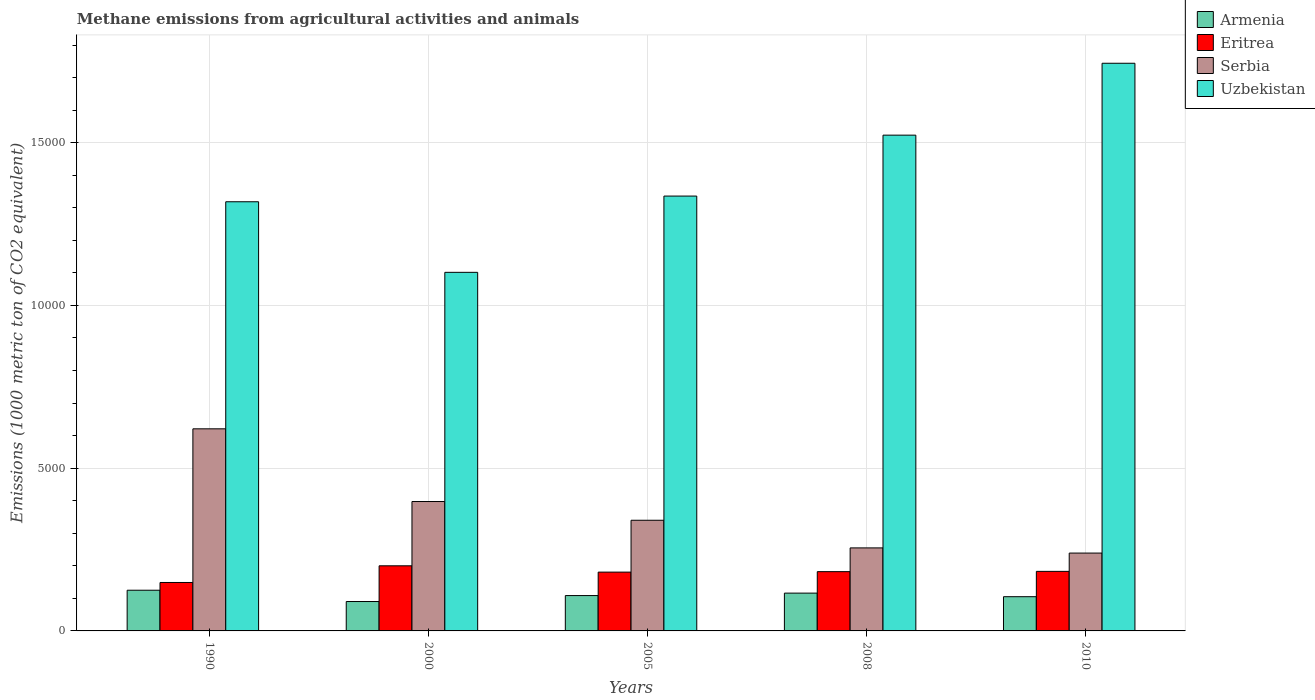How many different coloured bars are there?
Your response must be concise. 4. Are the number of bars per tick equal to the number of legend labels?
Offer a very short reply. Yes. What is the label of the 4th group of bars from the left?
Keep it short and to the point. 2008. In how many cases, is the number of bars for a given year not equal to the number of legend labels?
Your response must be concise. 0. What is the amount of methane emitted in Armenia in 1990?
Your response must be concise. 1250.4. Across all years, what is the maximum amount of methane emitted in Eritrea?
Your answer should be compact. 2000.3. Across all years, what is the minimum amount of methane emitted in Armenia?
Give a very brief answer. 903.1. In which year was the amount of methane emitted in Eritrea maximum?
Offer a very short reply. 2000. In which year was the amount of methane emitted in Uzbekistan minimum?
Provide a short and direct response. 2000. What is the total amount of methane emitted in Serbia in the graph?
Ensure brevity in your answer.  1.85e+04. What is the difference between the amount of methane emitted in Serbia in 2005 and that in 2010?
Offer a terse response. 1007.9. What is the difference between the amount of methane emitted in Eritrea in 2000 and the amount of methane emitted in Serbia in 1990?
Provide a short and direct response. -4208.5. What is the average amount of methane emitted in Eritrea per year?
Ensure brevity in your answer.  1789.12. In the year 2005, what is the difference between the amount of methane emitted in Serbia and amount of methane emitted in Eritrea?
Offer a very short reply. 1593. What is the ratio of the amount of methane emitted in Eritrea in 2000 to that in 2008?
Offer a terse response. 1.1. Is the amount of methane emitted in Eritrea in 2000 less than that in 2010?
Offer a very short reply. No. What is the difference between the highest and the second highest amount of methane emitted in Uzbekistan?
Provide a succinct answer. 2208.5. What is the difference between the highest and the lowest amount of methane emitted in Serbia?
Offer a terse response. 3817.1. Is the sum of the amount of methane emitted in Uzbekistan in 2008 and 2010 greater than the maximum amount of methane emitted in Serbia across all years?
Offer a very short reply. Yes. What does the 1st bar from the left in 2010 represents?
Keep it short and to the point. Armenia. What does the 2nd bar from the right in 2005 represents?
Your answer should be compact. Serbia. Is it the case that in every year, the sum of the amount of methane emitted in Eritrea and amount of methane emitted in Uzbekistan is greater than the amount of methane emitted in Armenia?
Offer a very short reply. Yes. What is the difference between two consecutive major ticks on the Y-axis?
Offer a very short reply. 5000. Are the values on the major ticks of Y-axis written in scientific E-notation?
Give a very brief answer. No. Does the graph contain any zero values?
Give a very brief answer. No. How many legend labels are there?
Your answer should be compact. 4. What is the title of the graph?
Provide a short and direct response. Methane emissions from agricultural activities and animals. What is the label or title of the Y-axis?
Offer a very short reply. Emissions (1000 metric ton of CO2 equivalent). What is the Emissions (1000 metric ton of CO2 equivalent) in Armenia in 1990?
Offer a very short reply. 1250.4. What is the Emissions (1000 metric ton of CO2 equivalent) of Eritrea in 1990?
Give a very brief answer. 1488.1. What is the Emissions (1000 metric ton of CO2 equivalent) in Serbia in 1990?
Ensure brevity in your answer.  6208.8. What is the Emissions (1000 metric ton of CO2 equivalent) of Uzbekistan in 1990?
Your response must be concise. 1.32e+04. What is the Emissions (1000 metric ton of CO2 equivalent) of Armenia in 2000?
Ensure brevity in your answer.  903.1. What is the Emissions (1000 metric ton of CO2 equivalent) in Eritrea in 2000?
Your answer should be compact. 2000.3. What is the Emissions (1000 metric ton of CO2 equivalent) of Serbia in 2000?
Your answer should be compact. 3975.3. What is the Emissions (1000 metric ton of CO2 equivalent) of Uzbekistan in 2000?
Offer a terse response. 1.10e+04. What is the Emissions (1000 metric ton of CO2 equivalent) in Armenia in 2005?
Offer a very short reply. 1086. What is the Emissions (1000 metric ton of CO2 equivalent) of Eritrea in 2005?
Keep it short and to the point. 1806.6. What is the Emissions (1000 metric ton of CO2 equivalent) in Serbia in 2005?
Your answer should be compact. 3399.6. What is the Emissions (1000 metric ton of CO2 equivalent) in Uzbekistan in 2005?
Ensure brevity in your answer.  1.34e+04. What is the Emissions (1000 metric ton of CO2 equivalent) of Armenia in 2008?
Your response must be concise. 1161.5. What is the Emissions (1000 metric ton of CO2 equivalent) of Eritrea in 2008?
Make the answer very short. 1820.8. What is the Emissions (1000 metric ton of CO2 equivalent) of Serbia in 2008?
Keep it short and to the point. 2550.7. What is the Emissions (1000 metric ton of CO2 equivalent) in Uzbekistan in 2008?
Offer a very short reply. 1.52e+04. What is the Emissions (1000 metric ton of CO2 equivalent) of Armenia in 2010?
Your response must be concise. 1051.7. What is the Emissions (1000 metric ton of CO2 equivalent) of Eritrea in 2010?
Offer a very short reply. 1829.8. What is the Emissions (1000 metric ton of CO2 equivalent) of Serbia in 2010?
Offer a very short reply. 2391.7. What is the Emissions (1000 metric ton of CO2 equivalent) of Uzbekistan in 2010?
Make the answer very short. 1.74e+04. Across all years, what is the maximum Emissions (1000 metric ton of CO2 equivalent) in Armenia?
Keep it short and to the point. 1250.4. Across all years, what is the maximum Emissions (1000 metric ton of CO2 equivalent) of Eritrea?
Your answer should be very brief. 2000.3. Across all years, what is the maximum Emissions (1000 metric ton of CO2 equivalent) in Serbia?
Your answer should be compact. 6208.8. Across all years, what is the maximum Emissions (1000 metric ton of CO2 equivalent) of Uzbekistan?
Give a very brief answer. 1.74e+04. Across all years, what is the minimum Emissions (1000 metric ton of CO2 equivalent) of Armenia?
Give a very brief answer. 903.1. Across all years, what is the minimum Emissions (1000 metric ton of CO2 equivalent) in Eritrea?
Your answer should be compact. 1488.1. Across all years, what is the minimum Emissions (1000 metric ton of CO2 equivalent) of Serbia?
Ensure brevity in your answer.  2391.7. Across all years, what is the minimum Emissions (1000 metric ton of CO2 equivalent) in Uzbekistan?
Provide a short and direct response. 1.10e+04. What is the total Emissions (1000 metric ton of CO2 equivalent) in Armenia in the graph?
Give a very brief answer. 5452.7. What is the total Emissions (1000 metric ton of CO2 equivalent) in Eritrea in the graph?
Make the answer very short. 8945.6. What is the total Emissions (1000 metric ton of CO2 equivalent) of Serbia in the graph?
Ensure brevity in your answer.  1.85e+04. What is the total Emissions (1000 metric ton of CO2 equivalent) in Uzbekistan in the graph?
Offer a very short reply. 7.02e+04. What is the difference between the Emissions (1000 metric ton of CO2 equivalent) in Armenia in 1990 and that in 2000?
Make the answer very short. 347.3. What is the difference between the Emissions (1000 metric ton of CO2 equivalent) in Eritrea in 1990 and that in 2000?
Make the answer very short. -512.2. What is the difference between the Emissions (1000 metric ton of CO2 equivalent) of Serbia in 1990 and that in 2000?
Give a very brief answer. 2233.5. What is the difference between the Emissions (1000 metric ton of CO2 equivalent) of Uzbekistan in 1990 and that in 2000?
Ensure brevity in your answer.  2168. What is the difference between the Emissions (1000 metric ton of CO2 equivalent) in Armenia in 1990 and that in 2005?
Offer a terse response. 164.4. What is the difference between the Emissions (1000 metric ton of CO2 equivalent) of Eritrea in 1990 and that in 2005?
Provide a succinct answer. -318.5. What is the difference between the Emissions (1000 metric ton of CO2 equivalent) in Serbia in 1990 and that in 2005?
Offer a terse response. 2809.2. What is the difference between the Emissions (1000 metric ton of CO2 equivalent) in Uzbekistan in 1990 and that in 2005?
Offer a very short reply. -174.6. What is the difference between the Emissions (1000 metric ton of CO2 equivalent) of Armenia in 1990 and that in 2008?
Your answer should be compact. 88.9. What is the difference between the Emissions (1000 metric ton of CO2 equivalent) of Eritrea in 1990 and that in 2008?
Ensure brevity in your answer.  -332.7. What is the difference between the Emissions (1000 metric ton of CO2 equivalent) of Serbia in 1990 and that in 2008?
Give a very brief answer. 3658.1. What is the difference between the Emissions (1000 metric ton of CO2 equivalent) of Uzbekistan in 1990 and that in 2008?
Provide a succinct answer. -2046.5. What is the difference between the Emissions (1000 metric ton of CO2 equivalent) of Armenia in 1990 and that in 2010?
Offer a terse response. 198.7. What is the difference between the Emissions (1000 metric ton of CO2 equivalent) in Eritrea in 1990 and that in 2010?
Your answer should be compact. -341.7. What is the difference between the Emissions (1000 metric ton of CO2 equivalent) of Serbia in 1990 and that in 2010?
Ensure brevity in your answer.  3817.1. What is the difference between the Emissions (1000 metric ton of CO2 equivalent) in Uzbekistan in 1990 and that in 2010?
Provide a succinct answer. -4255. What is the difference between the Emissions (1000 metric ton of CO2 equivalent) of Armenia in 2000 and that in 2005?
Provide a short and direct response. -182.9. What is the difference between the Emissions (1000 metric ton of CO2 equivalent) of Eritrea in 2000 and that in 2005?
Keep it short and to the point. 193.7. What is the difference between the Emissions (1000 metric ton of CO2 equivalent) of Serbia in 2000 and that in 2005?
Keep it short and to the point. 575.7. What is the difference between the Emissions (1000 metric ton of CO2 equivalent) in Uzbekistan in 2000 and that in 2005?
Provide a short and direct response. -2342.6. What is the difference between the Emissions (1000 metric ton of CO2 equivalent) of Armenia in 2000 and that in 2008?
Keep it short and to the point. -258.4. What is the difference between the Emissions (1000 metric ton of CO2 equivalent) in Eritrea in 2000 and that in 2008?
Give a very brief answer. 179.5. What is the difference between the Emissions (1000 metric ton of CO2 equivalent) in Serbia in 2000 and that in 2008?
Ensure brevity in your answer.  1424.6. What is the difference between the Emissions (1000 metric ton of CO2 equivalent) of Uzbekistan in 2000 and that in 2008?
Provide a succinct answer. -4214.5. What is the difference between the Emissions (1000 metric ton of CO2 equivalent) in Armenia in 2000 and that in 2010?
Provide a short and direct response. -148.6. What is the difference between the Emissions (1000 metric ton of CO2 equivalent) in Eritrea in 2000 and that in 2010?
Keep it short and to the point. 170.5. What is the difference between the Emissions (1000 metric ton of CO2 equivalent) of Serbia in 2000 and that in 2010?
Your answer should be compact. 1583.6. What is the difference between the Emissions (1000 metric ton of CO2 equivalent) in Uzbekistan in 2000 and that in 2010?
Your answer should be compact. -6423. What is the difference between the Emissions (1000 metric ton of CO2 equivalent) of Armenia in 2005 and that in 2008?
Offer a very short reply. -75.5. What is the difference between the Emissions (1000 metric ton of CO2 equivalent) in Eritrea in 2005 and that in 2008?
Offer a terse response. -14.2. What is the difference between the Emissions (1000 metric ton of CO2 equivalent) of Serbia in 2005 and that in 2008?
Provide a succinct answer. 848.9. What is the difference between the Emissions (1000 metric ton of CO2 equivalent) in Uzbekistan in 2005 and that in 2008?
Give a very brief answer. -1871.9. What is the difference between the Emissions (1000 metric ton of CO2 equivalent) in Armenia in 2005 and that in 2010?
Offer a very short reply. 34.3. What is the difference between the Emissions (1000 metric ton of CO2 equivalent) of Eritrea in 2005 and that in 2010?
Give a very brief answer. -23.2. What is the difference between the Emissions (1000 metric ton of CO2 equivalent) of Serbia in 2005 and that in 2010?
Your response must be concise. 1007.9. What is the difference between the Emissions (1000 metric ton of CO2 equivalent) of Uzbekistan in 2005 and that in 2010?
Offer a very short reply. -4080.4. What is the difference between the Emissions (1000 metric ton of CO2 equivalent) in Armenia in 2008 and that in 2010?
Your response must be concise. 109.8. What is the difference between the Emissions (1000 metric ton of CO2 equivalent) of Eritrea in 2008 and that in 2010?
Make the answer very short. -9. What is the difference between the Emissions (1000 metric ton of CO2 equivalent) of Serbia in 2008 and that in 2010?
Your answer should be very brief. 159. What is the difference between the Emissions (1000 metric ton of CO2 equivalent) of Uzbekistan in 2008 and that in 2010?
Offer a very short reply. -2208.5. What is the difference between the Emissions (1000 metric ton of CO2 equivalent) of Armenia in 1990 and the Emissions (1000 metric ton of CO2 equivalent) of Eritrea in 2000?
Offer a very short reply. -749.9. What is the difference between the Emissions (1000 metric ton of CO2 equivalent) of Armenia in 1990 and the Emissions (1000 metric ton of CO2 equivalent) of Serbia in 2000?
Ensure brevity in your answer.  -2724.9. What is the difference between the Emissions (1000 metric ton of CO2 equivalent) of Armenia in 1990 and the Emissions (1000 metric ton of CO2 equivalent) of Uzbekistan in 2000?
Offer a very short reply. -9766. What is the difference between the Emissions (1000 metric ton of CO2 equivalent) in Eritrea in 1990 and the Emissions (1000 metric ton of CO2 equivalent) in Serbia in 2000?
Give a very brief answer. -2487.2. What is the difference between the Emissions (1000 metric ton of CO2 equivalent) of Eritrea in 1990 and the Emissions (1000 metric ton of CO2 equivalent) of Uzbekistan in 2000?
Ensure brevity in your answer.  -9528.3. What is the difference between the Emissions (1000 metric ton of CO2 equivalent) in Serbia in 1990 and the Emissions (1000 metric ton of CO2 equivalent) in Uzbekistan in 2000?
Provide a succinct answer. -4807.6. What is the difference between the Emissions (1000 metric ton of CO2 equivalent) of Armenia in 1990 and the Emissions (1000 metric ton of CO2 equivalent) of Eritrea in 2005?
Provide a short and direct response. -556.2. What is the difference between the Emissions (1000 metric ton of CO2 equivalent) of Armenia in 1990 and the Emissions (1000 metric ton of CO2 equivalent) of Serbia in 2005?
Keep it short and to the point. -2149.2. What is the difference between the Emissions (1000 metric ton of CO2 equivalent) in Armenia in 1990 and the Emissions (1000 metric ton of CO2 equivalent) in Uzbekistan in 2005?
Your answer should be very brief. -1.21e+04. What is the difference between the Emissions (1000 metric ton of CO2 equivalent) of Eritrea in 1990 and the Emissions (1000 metric ton of CO2 equivalent) of Serbia in 2005?
Give a very brief answer. -1911.5. What is the difference between the Emissions (1000 metric ton of CO2 equivalent) in Eritrea in 1990 and the Emissions (1000 metric ton of CO2 equivalent) in Uzbekistan in 2005?
Keep it short and to the point. -1.19e+04. What is the difference between the Emissions (1000 metric ton of CO2 equivalent) of Serbia in 1990 and the Emissions (1000 metric ton of CO2 equivalent) of Uzbekistan in 2005?
Offer a very short reply. -7150.2. What is the difference between the Emissions (1000 metric ton of CO2 equivalent) in Armenia in 1990 and the Emissions (1000 metric ton of CO2 equivalent) in Eritrea in 2008?
Ensure brevity in your answer.  -570.4. What is the difference between the Emissions (1000 metric ton of CO2 equivalent) in Armenia in 1990 and the Emissions (1000 metric ton of CO2 equivalent) in Serbia in 2008?
Ensure brevity in your answer.  -1300.3. What is the difference between the Emissions (1000 metric ton of CO2 equivalent) of Armenia in 1990 and the Emissions (1000 metric ton of CO2 equivalent) of Uzbekistan in 2008?
Keep it short and to the point. -1.40e+04. What is the difference between the Emissions (1000 metric ton of CO2 equivalent) of Eritrea in 1990 and the Emissions (1000 metric ton of CO2 equivalent) of Serbia in 2008?
Provide a succinct answer. -1062.6. What is the difference between the Emissions (1000 metric ton of CO2 equivalent) of Eritrea in 1990 and the Emissions (1000 metric ton of CO2 equivalent) of Uzbekistan in 2008?
Provide a succinct answer. -1.37e+04. What is the difference between the Emissions (1000 metric ton of CO2 equivalent) of Serbia in 1990 and the Emissions (1000 metric ton of CO2 equivalent) of Uzbekistan in 2008?
Offer a very short reply. -9022.1. What is the difference between the Emissions (1000 metric ton of CO2 equivalent) in Armenia in 1990 and the Emissions (1000 metric ton of CO2 equivalent) in Eritrea in 2010?
Your answer should be very brief. -579.4. What is the difference between the Emissions (1000 metric ton of CO2 equivalent) in Armenia in 1990 and the Emissions (1000 metric ton of CO2 equivalent) in Serbia in 2010?
Give a very brief answer. -1141.3. What is the difference between the Emissions (1000 metric ton of CO2 equivalent) in Armenia in 1990 and the Emissions (1000 metric ton of CO2 equivalent) in Uzbekistan in 2010?
Make the answer very short. -1.62e+04. What is the difference between the Emissions (1000 metric ton of CO2 equivalent) in Eritrea in 1990 and the Emissions (1000 metric ton of CO2 equivalent) in Serbia in 2010?
Your response must be concise. -903.6. What is the difference between the Emissions (1000 metric ton of CO2 equivalent) in Eritrea in 1990 and the Emissions (1000 metric ton of CO2 equivalent) in Uzbekistan in 2010?
Offer a terse response. -1.60e+04. What is the difference between the Emissions (1000 metric ton of CO2 equivalent) of Serbia in 1990 and the Emissions (1000 metric ton of CO2 equivalent) of Uzbekistan in 2010?
Ensure brevity in your answer.  -1.12e+04. What is the difference between the Emissions (1000 metric ton of CO2 equivalent) in Armenia in 2000 and the Emissions (1000 metric ton of CO2 equivalent) in Eritrea in 2005?
Provide a succinct answer. -903.5. What is the difference between the Emissions (1000 metric ton of CO2 equivalent) of Armenia in 2000 and the Emissions (1000 metric ton of CO2 equivalent) of Serbia in 2005?
Ensure brevity in your answer.  -2496.5. What is the difference between the Emissions (1000 metric ton of CO2 equivalent) in Armenia in 2000 and the Emissions (1000 metric ton of CO2 equivalent) in Uzbekistan in 2005?
Keep it short and to the point. -1.25e+04. What is the difference between the Emissions (1000 metric ton of CO2 equivalent) of Eritrea in 2000 and the Emissions (1000 metric ton of CO2 equivalent) of Serbia in 2005?
Offer a terse response. -1399.3. What is the difference between the Emissions (1000 metric ton of CO2 equivalent) in Eritrea in 2000 and the Emissions (1000 metric ton of CO2 equivalent) in Uzbekistan in 2005?
Make the answer very short. -1.14e+04. What is the difference between the Emissions (1000 metric ton of CO2 equivalent) of Serbia in 2000 and the Emissions (1000 metric ton of CO2 equivalent) of Uzbekistan in 2005?
Your response must be concise. -9383.7. What is the difference between the Emissions (1000 metric ton of CO2 equivalent) of Armenia in 2000 and the Emissions (1000 metric ton of CO2 equivalent) of Eritrea in 2008?
Keep it short and to the point. -917.7. What is the difference between the Emissions (1000 metric ton of CO2 equivalent) of Armenia in 2000 and the Emissions (1000 metric ton of CO2 equivalent) of Serbia in 2008?
Your answer should be compact. -1647.6. What is the difference between the Emissions (1000 metric ton of CO2 equivalent) in Armenia in 2000 and the Emissions (1000 metric ton of CO2 equivalent) in Uzbekistan in 2008?
Ensure brevity in your answer.  -1.43e+04. What is the difference between the Emissions (1000 metric ton of CO2 equivalent) of Eritrea in 2000 and the Emissions (1000 metric ton of CO2 equivalent) of Serbia in 2008?
Ensure brevity in your answer.  -550.4. What is the difference between the Emissions (1000 metric ton of CO2 equivalent) in Eritrea in 2000 and the Emissions (1000 metric ton of CO2 equivalent) in Uzbekistan in 2008?
Your response must be concise. -1.32e+04. What is the difference between the Emissions (1000 metric ton of CO2 equivalent) of Serbia in 2000 and the Emissions (1000 metric ton of CO2 equivalent) of Uzbekistan in 2008?
Offer a terse response. -1.13e+04. What is the difference between the Emissions (1000 metric ton of CO2 equivalent) of Armenia in 2000 and the Emissions (1000 metric ton of CO2 equivalent) of Eritrea in 2010?
Your response must be concise. -926.7. What is the difference between the Emissions (1000 metric ton of CO2 equivalent) in Armenia in 2000 and the Emissions (1000 metric ton of CO2 equivalent) in Serbia in 2010?
Ensure brevity in your answer.  -1488.6. What is the difference between the Emissions (1000 metric ton of CO2 equivalent) of Armenia in 2000 and the Emissions (1000 metric ton of CO2 equivalent) of Uzbekistan in 2010?
Your answer should be very brief. -1.65e+04. What is the difference between the Emissions (1000 metric ton of CO2 equivalent) in Eritrea in 2000 and the Emissions (1000 metric ton of CO2 equivalent) in Serbia in 2010?
Keep it short and to the point. -391.4. What is the difference between the Emissions (1000 metric ton of CO2 equivalent) in Eritrea in 2000 and the Emissions (1000 metric ton of CO2 equivalent) in Uzbekistan in 2010?
Offer a very short reply. -1.54e+04. What is the difference between the Emissions (1000 metric ton of CO2 equivalent) of Serbia in 2000 and the Emissions (1000 metric ton of CO2 equivalent) of Uzbekistan in 2010?
Your answer should be very brief. -1.35e+04. What is the difference between the Emissions (1000 metric ton of CO2 equivalent) of Armenia in 2005 and the Emissions (1000 metric ton of CO2 equivalent) of Eritrea in 2008?
Your answer should be very brief. -734.8. What is the difference between the Emissions (1000 metric ton of CO2 equivalent) in Armenia in 2005 and the Emissions (1000 metric ton of CO2 equivalent) in Serbia in 2008?
Your answer should be compact. -1464.7. What is the difference between the Emissions (1000 metric ton of CO2 equivalent) in Armenia in 2005 and the Emissions (1000 metric ton of CO2 equivalent) in Uzbekistan in 2008?
Your answer should be very brief. -1.41e+04. What is the difference between the Emissions (1000 metric ton of CO2 equivalent) of Eritrea in 2005 and the Emissions (1000 metric ton of CO2 equivalent) of Serbia in 2008?
Your response must be concise. -744.1. What is the difference between the Emissions (1000 metric ton of CO2 equivalent) of Eritrea in 2005 and the Emissions (1000 metric ton of CO2 equivalent) of Uzbekistan in 2008?
Make the answer very short. -1.34e+04. What is the difference between the Emissions (1000 metric ton of CO2 equivalent) in Serbia in 2005 and the Emissions (1000 metric ton of CO2 equivalent) in Uzbekistan in 2008?
Your response must be concise. -1.18e+04. What is the difference between the Emissions (1000 metric ton of CO2 equivalent) in Armenia in 2005 and the Emissions (1000 metric ton of CO2 equivalent) in Eritrea in 2010?
Give a very brief answer. -743.8. What is the difference between the Emissions (1000 metric ton of CO2 equivalent) of Armenia in 2005 and the Emissions (1000 metric ton of CO2 equivalent) of Serbia in 2010?
Your answer should be compact. -1305.7. What is the difference between the Emissions (1000 metric ton of CO2 equivalent) of Armenia in 2005 and the Emissions (1000 metric ton of CO2 equivalent) of Uzbekistan in 2010?
Provide a short and direct response. -1.64e+04. What is the difference between the Emissions (1000 metric ton of CO2 equivalent) of Eritrea in 2005 and the Emissions (1000 metric ton of CO2 equivalent) of Serbia in 2010?
Provide a short and direct response. -585.1. What is the difference between the Emissions (1000 metric ton of CO2 equivalent) of Eritrea in 2005 and the Emissions (1000 metric ton of CO2 equivalent) of Uzbekistan in 2010?
Your response must be concise. -1.56e+04. What is the difference between the Emissions (1000 metric ton of CO2 equivalent) in Serbia in 2005 and the Emissions (1000 metric ton of CO2 equivalent) in Uzbekistan in 2010?
Offer a very short reply. -1.40e+04. What is the difference between the Emissions (1000 metric ton of CO2 equivalent) in Armenia in 2008 and the Emissions (1000 metric ton of CO2 equivalent) in Eritrea in 2010?
Keep it short and to the point. -668.3. What is the difference between the Emissions (1000 metric ton of CO2 equivalent) in Armenia in 2008 and the Emissions (1000 metric ton of CO2 equivalent) in Serbia in 2010?
Offer a very short reply. -1230.2. What is the difference between the Emissions (1000 metric ton of CO2 equivalent) in Armenia in 2008 and the Emissions (1000 metric ton of CO2 equivalent) in Uzbekistan in 2010?
Provide a short and direct response. -1.63e+04. What is the difference between the Emissions (1000 metric ton of CO2 equivalent) in Eritrea in 2008 and the Emissions (1000 metric ton of CO2 equivalent) in Serbia in 2010?
Your answer should be very brief. -570.9. What is the difference between the Emissions (1000 metric ton of CO2 equivalent) in Eritrea in 2008 and the Emissions (1000 metric ton of CO2 equivalent) in Uzbekistan in 2010?
Your answer should be very brief. -1.56e+04. What is the difference between the Emissions (1000 metric ton of CO2 equivalent) of Serbia in 2008 and the Emissions (1000 metric ton of CO2 equivalent) of Uzbekistan in 2010?
Your answer should be compact. -1.49e+04. What is the average Emissions (1000 metric ton of CO2 equivalent) in Armenia per year?
Provide a succinct answer. 1090.54. What is the average Emissions (1000 metric ton of CO2 equivalent) in Eritrea per year?
Provide a short and direct response. 1789.12. What is the average Emissions (1000 metric ton of CO2 equivalent) of Serbia per year?
Offer a very short reply. 3705.22. What is the average Emissions (1000 metric ton of CO2 equivalent) in Uzbekistan per year?
Your response must be concise. 1.40e+04. In the year 1990, what is the difference between the Emissions (1000 metric ton of CO2 equivalent) in Armenia and Emissions (1000 metric ton of CO2 equivalent) in Eritrea?
Provide a succinct answer. -237.7. In the year 1990, what is the difference between the Emissions (1000 metric ton of CO2 equivalent) in Armenia and Emissions (1000 metric ton of CO2 equivalent) in Serbia?
Offer a very short reply. -4958.4. In the year 1990, what is the difference between the Emissions (1000 metric ton of CO2 equivalent) of Armenia and Emissions (1000 metric ton of CO2 equivalent) of Uzbekistan?
Your response must be concise. -1.19e+04. In the year 1990, what is the difference between the Emissions (1000 metric ton of CO2 equivalent) of Eritrea and Emissions (1000 metric ton of CO2 equivalent) of Serbia?
Make the answer very short. -4720.7. In the year 1990, what is the difference between the Emissions (1000 metric ton of CO2 equivalent) of Eritrea and Emissions (1000 metric ton of CO2 equivalent) of Uzbekistan?
Make the answer very short. -1.17e+04. In the year 1990, what is the difference between the Emissions (1000 metric ton of CO2 equivalent) of Serbia and Emissions (1000 metric ton of CO2 equivalent) of Uzbekistan?
Your answer should be very brief. -6975.6. In the year 2000, what is the difference between the Emissions (1000 metric ton of CO2 equivalent) of Armenia and Emissions (1000 metric ton of CO2 equivalent) of Eritrea?
Offer a terse response. -1097.2. In the year 2000, what is the difference between the Emissions (1000 metric ton of CO2 equivalent) of Armenia and Emissions (1000 metric ton of CO2 equivalent) of Serbia?
Give a very brief answer. -3072.2. In the year 2000, what is the difference between the Emissions (1000 metric ton of CO2 equivalent) in Armenia and Emissions (1000 metric ton of CO2 equivalent) in Uzbekistan?
Keep it short and to the point. -1.01e+04. In the year 2000, what is the difference between the Emissions (1000 metric ton of CO2 equivalent) in Eritrea and Emissions (1000 metric ton of CO2 equivalent) in Serbia?
Offer a very short reply. -1975. In the year 2000, what is the difference between the Emissions (1000 metric ton of CO2 equivalent) in Eritrea and Emissions (1000 metric ton of CO2 equivalent) in Uzbekistan?
Your response must be concise. -9016.1. In the year 2000, what is the difference between the Emissions (1000 metric ton of CO2 equivalent) of Serbia and Emissions (1000 metric ton of CO2 equivalent) of Uzbekistan?
Ensure brevity in your answer.  -7041.1. In the year 2005, what is the difference between the Emissions (1000 metric ton of CO2 equivalent) of Armenia and Emissions (1000 metric ton of CO2 equivalent) of Eritrea?
Offer a very short reply. -720.6. In the year 2005, what is the difference between the Emissions (1000 metric ton of CO2 equivalent) of Armenia and Emissions (1000 metric ton of CO2 equivalent) of Serbia?
Your response must be concise. -2313.6. In the year 2005, what is the difference between the Emissions (1000 metric ton of CO2 equivalent) of Armenia and Emissions (1000 metric ton of CO2 equivalent) of Uzbekistan?
Ensure brevity in your answer.  -1.23e+04. In the year 2005, what is the difference between the Emissions (1000 metric ton of CO2 equivalent) in Eritrea and Emissions (1000 metric ton of CO2 equivalent) in Serbia?
Provide a short and direct response. -1593. In the year 2005, what is the difference between the Emissions (1000 metric ton of CO2 equivalent) of Eritrea and Emissions (1000 metric ton of CO2 equivalent) of Uzbekistan?
Provide a short and direct response. -1.16e+04. In the year 2005, what is the difference between the Emissions (1000 metric ton of CO2 equivalent) of Serbia and Emissions (1000 metric ton of CO2 equivalent) of Uzbekistan?
Keep it short and to the point. -9959.4. In the year 2008, what is the difference between the Emissions (1000 metric ton of CO2 equivalent) of Armenia and Emissions (1000 metric ton of CO2 equivalent) of Eritrea?
Your response must be concise. -659.3. In the year 2008, what is the difference between the Emissions (1000 metric ton of CO2 equivalent) of Armenia and Emissions (1000 metric ton of CO2 equivalent) of Serbia?
Your answer should be compact. -1389.2. In the year 2008, what is the difference between the Emissions (1000 metric ton of CO2 equivalent) in Armenia and Emissions (1000 metric ton of CO2 equivalent) in Uzbekistan?
Ensure brevity in your answer.  -1.41e+04. In the year 2008, what is the difference between the Emissions (1000 metric ton of CO2 equivalent) in Eritrea and Emissions (1000 metric ton of CO2 equivalent) in Serbia?
Provide a short and direct response. -729.9. In the year 2008, what is the difference between the Emissions (1000 metric ton of CO2 equivalent) of Eritrea and Emissions (1000 metric ton of CO2 equivalent) of Uzbekistan?
Ensure brevity in your answer.  -1.34e+04. In the year 2008, what is the difference between the Emissions (1000 metric ton of CO2 equivalent) of Serbia and Emissions (1000 metric ton of CO2 equivalent) of Uzbekistan?
Offer a very short reply. -1.27e+04. In the year 2010, what is the difference between the Emissions (1000 metric ton of CO2 equivalent) of Armenia and Emissions (1000 metric ton of CO2 equivalent) of Eritrea?
Provide a succinct answer. -778.1. In the year 2010, what is the difference between the Emissions (1000 metric ton of CO2 equivalent) in Armenia and Emissions (1000 metric ton of CO2 equivalent) in Serbia?
Ensure brevity in your answer.  -1340. In the year 2010, what is the difference between the Emissions (1000 metric ton of CO2 equivalent) in Armenia and Emissions (1000 metric ton of CO2 equivalent) in Uzbekistan?
Provide a succinct answer. -1.64e+04. In the year 2010, what is the difference between the Emissions (1000 metric ton of CO2 equivalent) in Eritrea and Emissions (1000 metric ton of CO2 equivalent) in Serbia?
Keep it short and to the point. -561.9. In the year 2010, what is the difference between the Emissions (1000 metric ton of CO2 equivalent) in Eritrea and Emissions (1000 metric ton of CO2 equivalent) in Uzbekistan?
Give a very brief answer. -1.56e+04. In the year 2010, what is the difference between the Emissions (1000 metric ton of CO2 equivalent) in Serbia and Emissions (1000 metric ton of CO2 equivalent) in Uzbekistan?
Offer a very short reply. -1.50e+04. What is the ratio of the Emissions (1000 metric ton of CO2 equivalent) in Armenia in 1990 to that in 2000?
Your response must be concise. 1.38. What is the ratio of the Emissions (1000 metric ton of CO2 equivalent) in Eritrea in 1990 to that in 2000?
Offer a very short reply. 0.74. What is the ratio of the Emissions (1000 metric ton of CO2 equivalent) in Serbia in 1990 to that in 2000?
Your answer should be compact. 1.56. What is the ratio of the Emissions (1000 metric ton of CO2 equivalent) in Uzbekistan in 1990 to that in 2000?
Keep it short and to the point. 1.2. What is the ratio of the Emissions (1000 metric ton of CO2 equivalent) in Armenia in 1990 to that in 2005?
Offer a very short reply. 1.15. What is the ratio of the Emissions (1000 metric ton of CO2 equivalent) in Eritrea in 1990 to that in 2005?
Your response must be concise. 0.82. What is the ratio of the Emissions (1000 metric ton of CO2 equivalent) in Serbia in 1990 to that in 2005?
Your response must be concise. 1.83. What is the ratio of the Emissions (1000 metric ton of CO2 equivalent) of Uzbekistan in 1990 to that in 2005?
Offer a very short reply. 0.99. What is the ratio of the Emissions (1000 metric ton of CO2 equivalent) of Armenia in 1990 to that in 2008?
Your answer should be compact. 1.08. What is the ratio of the Emissions (1000 metric ton of CO2 equivalent) of Eritrea in 1990 to that in 2008?
Offer a terse response. 0.82. What is the ratio of the Emissions (1000 metric ton of CO2 equivalent) of Serbia in 1990 to that in 2008?
Offer a very short reply. 2.43. What is the ratio of the Emissions (1000 metric ton of CO2 equivalent) of Uzbekistan in 1990 to that in 2008?
Offer a very short reply. 0.87. What is the ratio of the Emissions (1000 metric ton of CO2 equivalent) in Armenia in 1990 to that in 2010?
Your answer should be very brief. 1.19. What is the ratio of the Emissions (1000 metric ton of CO2 equivalent) in Eritrea in 1990 to that in 2010?
Keep it short and to the point. 0.81. What is the ratio of the Emissions (1000 metric ton of CO2 equivalent) in Serbia in 1990 to that in 2010?
Ensure brevity in your answer.  2.6. What is the ratio of the Emissions (1000 metric ton of CO2 equivalent) of Uzbekistan in 1990 to that in 2010?
Your response must be concise. 0.76. What is the ratio of the Emissions (1000 metric ton of CO2 equivalent) of Armenia in 2000 to that in 2005?
Make the answer very short. 0.83. What is the ratio of the Emissions (1000 metric ton of CO2 equivalent) in Eritrea in 2000 to that in 2005?
Ensure brevity in your answer.  1.11. What is the ratio of the Emissions (1000 metric ton of CO2 equivalent) of Serbia in 2000 to that in 2005?
Give a very brief answer. 1.17. What is the ratio of the Emissions (1000 metric ton of CO2 equivalent) of Uzbekistan in 2000 to that in 2005?
Your answer should be compact. 0.82. What is the ratio of the Emissions (1000 metric ton of CO2 equivalent) in Armenia in 2000 to that in 2008?
Make the answer very short. 0.78. What is the ratio of the Emissions (1000 metric ton of CO2 equivalent) in Eritrea in 2000 to that in 2008?
Make the answer very short. 1.1. What is the ratio of the Emissions (1000 metric ton of CO2 equivalent) of Serbia in 2000 to that in 2008?
Provide a succinct answer. 1.56. What is the ratio of the Emissions (1000 metric ton of CO2 equivalent) of Uzbekistan in 2000 to that in 2008?
Offer a terse response. 0.72. What is the ratio of the Emissions (1000 metric ton of CO2 equivalent) of Armenia in 2000 to that in 2010?
Make the answer very short. 0.86. What is the ratio of the Emissions (1000 metric ton of CO2 equivalent) in Eritrea in 2000 to that in 2010?
Give a very brief answer. 1.09. What is the ratio of the Emissions (1000 metric ton of CO2 equivalent) in Serbia in 2000 to that in 2010?
Your answer should be very brief. 1.66. What is the ratio of the Emissions (1000 metric ton of CO2 equivalent) of Uzbekistan in 2000 to that in 2010?
Provide a short and direct response. 0.63. What is the ratio of the Emissions (1000 metric ton of CO2 equivalent) in Armenia in 2005 to that in 2008?
Your answer should be very brief. 0.94. What is the ratio of the Emissions (1000 metric ton of CO2 equivalent) in Eritrea in 2005 to that in 2008?
Offer a very short reply. 0.99. What is the ratio of the Emissions (1000 metric ton of CO2 equivalent) in Serbia in 2005 to that in 2008?
Keep it short and to the point. 1.33. What is the ratio of the Emissions (1000 metric ton of CO2 equivalent) of Uzbekistan in 2005 to that in 2008?
Provide a succinct answer. 0.88. What is the ratio of the Emissions (1000 metric ton of CO2 equivalent) in Armenia in 2005 to that in 2010?
Your answer should be very brief. 1.03. What is the ratio of the Emissions (1000 metric ton of CO2 equivalent) of Eritrea in 2005 to that in 2010?
Your answer should be very brief. 0.99. What is the ratio of the Emissions (1000 metric ton of CO2 equivalent) in Serbia in 2005 to that in 2010?
Ensure brevity in your answer.  1.42. What is the ratio of the Emissions (1000 metric ton of CO2 equivalent) in Uzbekistan in 2005 to that in 2010?
Give a very brief answer. 0.77. What is the ratio of the Emissions (1000 metric ton of CO2 equivalent) in Armenia in 2008 to that in 2010?
Ensure brevity in your answer.  1.1. What is the ratio of the Emissions (1000 metric ton of CO2 equivalent) in Serbia in 2008 to that in 2010?
Provide a succinct answer. 1.07. What is the ratio of the Emissions (1000 metric ton of CO2 equivalent) of Uzbekistan in 2008 to that in 2010?
Keep it short and to the point. 0.87. What is the difference between the highest and the second highest Emissions (1000 metric ton of CO2 equivalent) in Armenia?
Ensure brevity in your answer.  88.9. What is the difference between the highest and the second highest Emissions (1000 metric ton of CO2 equivalent) of Eritrea?
Keep it short and to the point. 170.5. What is the difference between the highest and the second highest Emissions (1000 metric ton of CO2 equivalent) of Serbia?
Give a very brief answer. 2233.5. What is the difference between the highest and the second highest Emissions (1000 metric ton of CO2 equivalent) in Uzbekistan?
Your answer should be very brief. 2208.5. What is the difference between the highest and the lowest Emissions (1000 metric ton of CO2 equivalent) in Armenia?
Provide a short and direct response. 347.3. What is the difference between the highest and the lowest Emissions (1000 metric ton of CO2 equivalent) in Eritrea?
Keep it short and to the point. 512.2. What is the difference between the highest and the lowest Emissions (1000 metric ton of CO2 equivalent) of Serbia?
Provide a short and direct response. 3817.1. What is the difference between the highest and the lowest Emissions (1000 metric ton of CO2 equivalent) of Uzbekistan?
Your answer should be compact. 6423. 